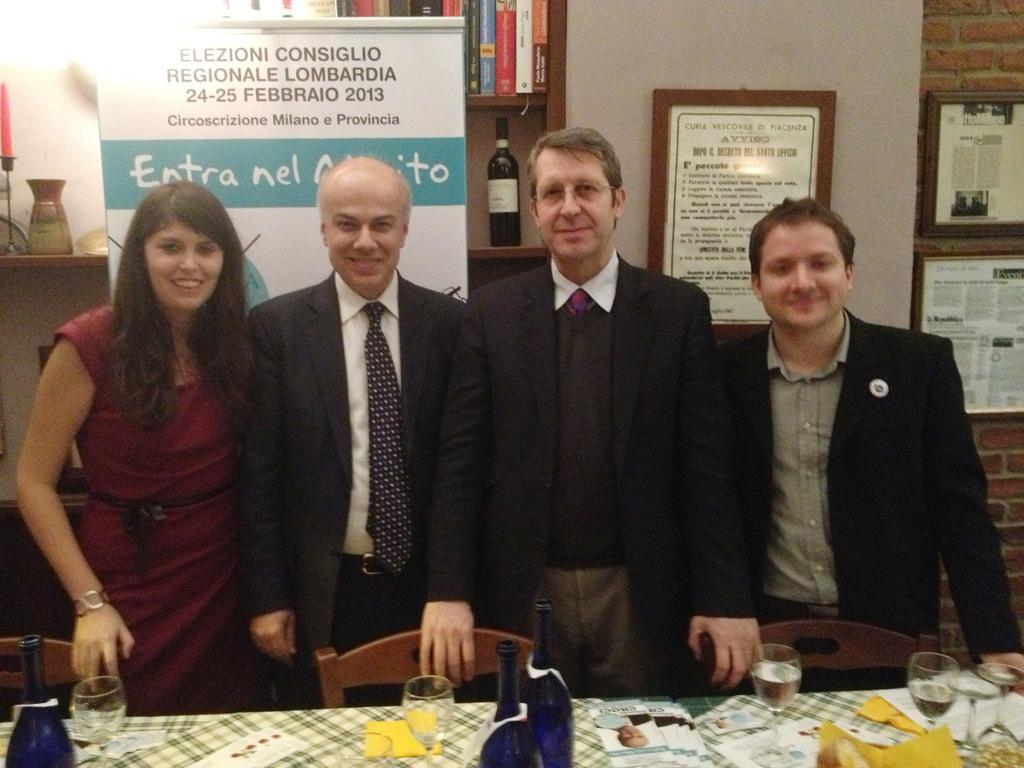How many people are standing in the image? There are four persons standing in the image. What type of furniture is present in the image? There are chairs and a table in the image. What is placed on the table? There are objects placed on the table. What type of storage is visible in the image? There is a book shelf in the image. What type of decorative item is present in the image? There is a photo frame in the image. What type of flowers are being read by the persons in the image? There are no flowers or reading activity depicted in the image. 